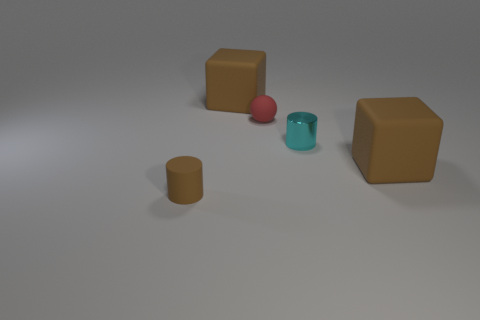Add 5 small rubber objects. How many objects exist? 10 Subtract all cylinders. How many objects are left? 3 Subtract all tiny red matte balls. Subtract all metal cylinders. How many objects are left? 3 Add 5 rubber cylinders. How many rubber cylinders are left? 6 Add 3 red spheres. How many red spheres exist? 4 Subtract 0 gray cylinders. How many objects are left? 5 